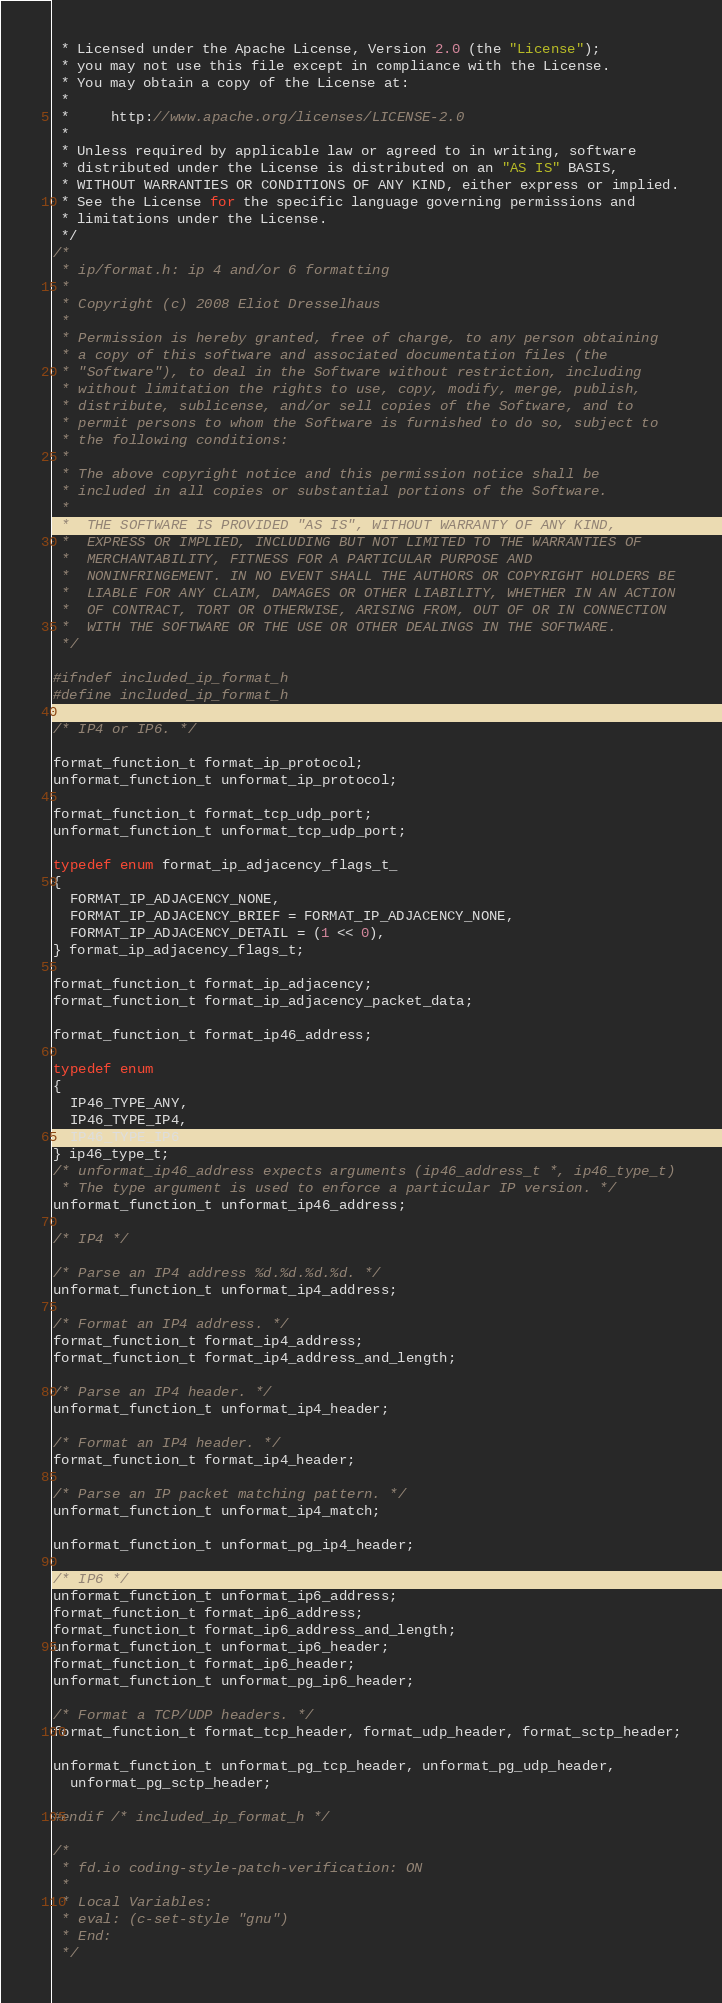Convert code to text. <code><loc_0><loc_0><loc_500><loc_500><_C_> * Licensed under the Apache License, Version 2.0 (the "License");
 * you may not use this file except in compliance with the License.
 * You may obtain a copy of the License at:
 *
 *     http://www.apache.org/licenses/LICENSE-2.0
 *
 * Unless required by applicable law or agreed to in writing, software
 * distributed under the License is distributed on an "AS IS" BASIS,
 * WITHOUT WARRANTIES OR CONDITIONS OF ANY KIND, either express or implied.
 * See the License for the specific language governing permissions and
 * limitations under the License.
 */
/*
 * ip/format.h: ip 4 and/or 6 formatting
 *
 * Copyright (c) 2008 Eliot Dresselhaus
 *
 * Permission is hereby granted, free of charge, to any person obtaining
 * a copy of this software and associated documentation files (the
 * "Software"), to deal in the Software without restriction, including
 * without limitation the rights to use, copy, modify, merge, publish,
 * distribute, sublicense, and/or sell copies of the Software, and to
 * permit persons to whom the Software is furnished to do so, subject to
 * the following conditions:
 *
 * The above copyright notice and this permission notice shall be
 * included in all copies or substantial portions of the Software.
 *
 *  THE SOFTWARE IS PROVIDED "AS IS", WITHOUT WARRANTY OF ANY KIND,
 *  EXPRESS OR IMPLIED, INCLUDING BUT NOT LIMITED TO THE WARRANTIES OF
 *  MERCHANTABILITY, FITNESS FOR A PARTICULAR PURPOSE AND
 *  NONINFRINGEMENT. IN NO EVENT SHALL THE AUTHORS OR COPYRIGHT HOLDERS BE
 *  LIABLE FOR ANY CLAIM, DAMAGES OR OTHER LIABILITY, WHETHER IN AN ACTION
 *  OF CONTRACT, TORT OR OTHERWISE, ARISING FROM, OUT OF OR IN CONNECTION
 *  WITH THE SOFTWARE OR THE USE OR OTHER DEALINGS IN THE SOFTWARE.
 */

#ifndef included_ip_format_h
#define included_ip_format_h

/* IP4 or IP6. */

format_function_t format_ip_protocol;
unformat_function_t unformat_ip_protocol;

format_function_t format_tcp_udp_port;
unformat_function_t unformat_tcp_udp_port;

typedef enum format_ip_adjacency_flags_t_
{
  FORMAT_IP_ADJACENCY_NONE,
  FORMAT_IP_ADJACENCY_BRIEF = FORMAT_IP_ADJACENCY_NONE,
  FORMAT_IP_ADJACENCY_DETAIL = (1 << 0),
} format_ip_adjacency_flags_t;

format_function_t format_ip_adjacency;
format_function_t format_ip_adjacency_packet_data;

format_function_t format_ip46_address;

typedef enum
{
  IP46_TYPE_ANY,
  IP46_TYPE_IP4,
  IP46_TYPE_IP6
} ip46_type_t;
/* unformat_ip46_address expects arguments (ip46_address_t *, ip46_type_t)
 * The type argument is used to enforce a particular IP version. */
unformat_function_t unformat_ip46_address;

/* IP4 */

/* Parse an IP4 address %d.%d.%d.%d. */
unformat_function_t unformat_ip4_address;

/* Format an IP4 address. */
format_function_t format_ip4_address;
format_function_t format_ip4_address_and_length;

/* Parse an IP4 header. */
unformat_function_t unformat_ip4_header;

/* Format an IP4 header. */
format_function_t format_ip4_header;

/* Parse an IP packet matching pattern. */
unformat_function_t unformat_ip4_match;

unformat_function_t unformat_pg_ip4_header;

/* IP6 */
unformat_function_t unformat_ip6_address;
format_function_t format_ip6_address;
format_function_t format_ip6_address_and_length;
unformat_function_t unformat_ip6_header;
format_function_t format_ip6_header;
unformat_function_t unformat_pg_ip6_header;

/* Format a TCP/UDP headers. */
format_function_t format_tcp_header, format_udp_header, format_sctp_header;

unformat_function_t unformat_pg_tcp_header, unformat_pg_udp_header,
  unformat_pg_sctp_header;

#endif /* included_ip_format_h */

/*
 * fd.io coding-style-patch-verification: ON
 *
 * Local Variables:
 * eval: (c-set-style "gnu")
 * End:
 */
</code> 